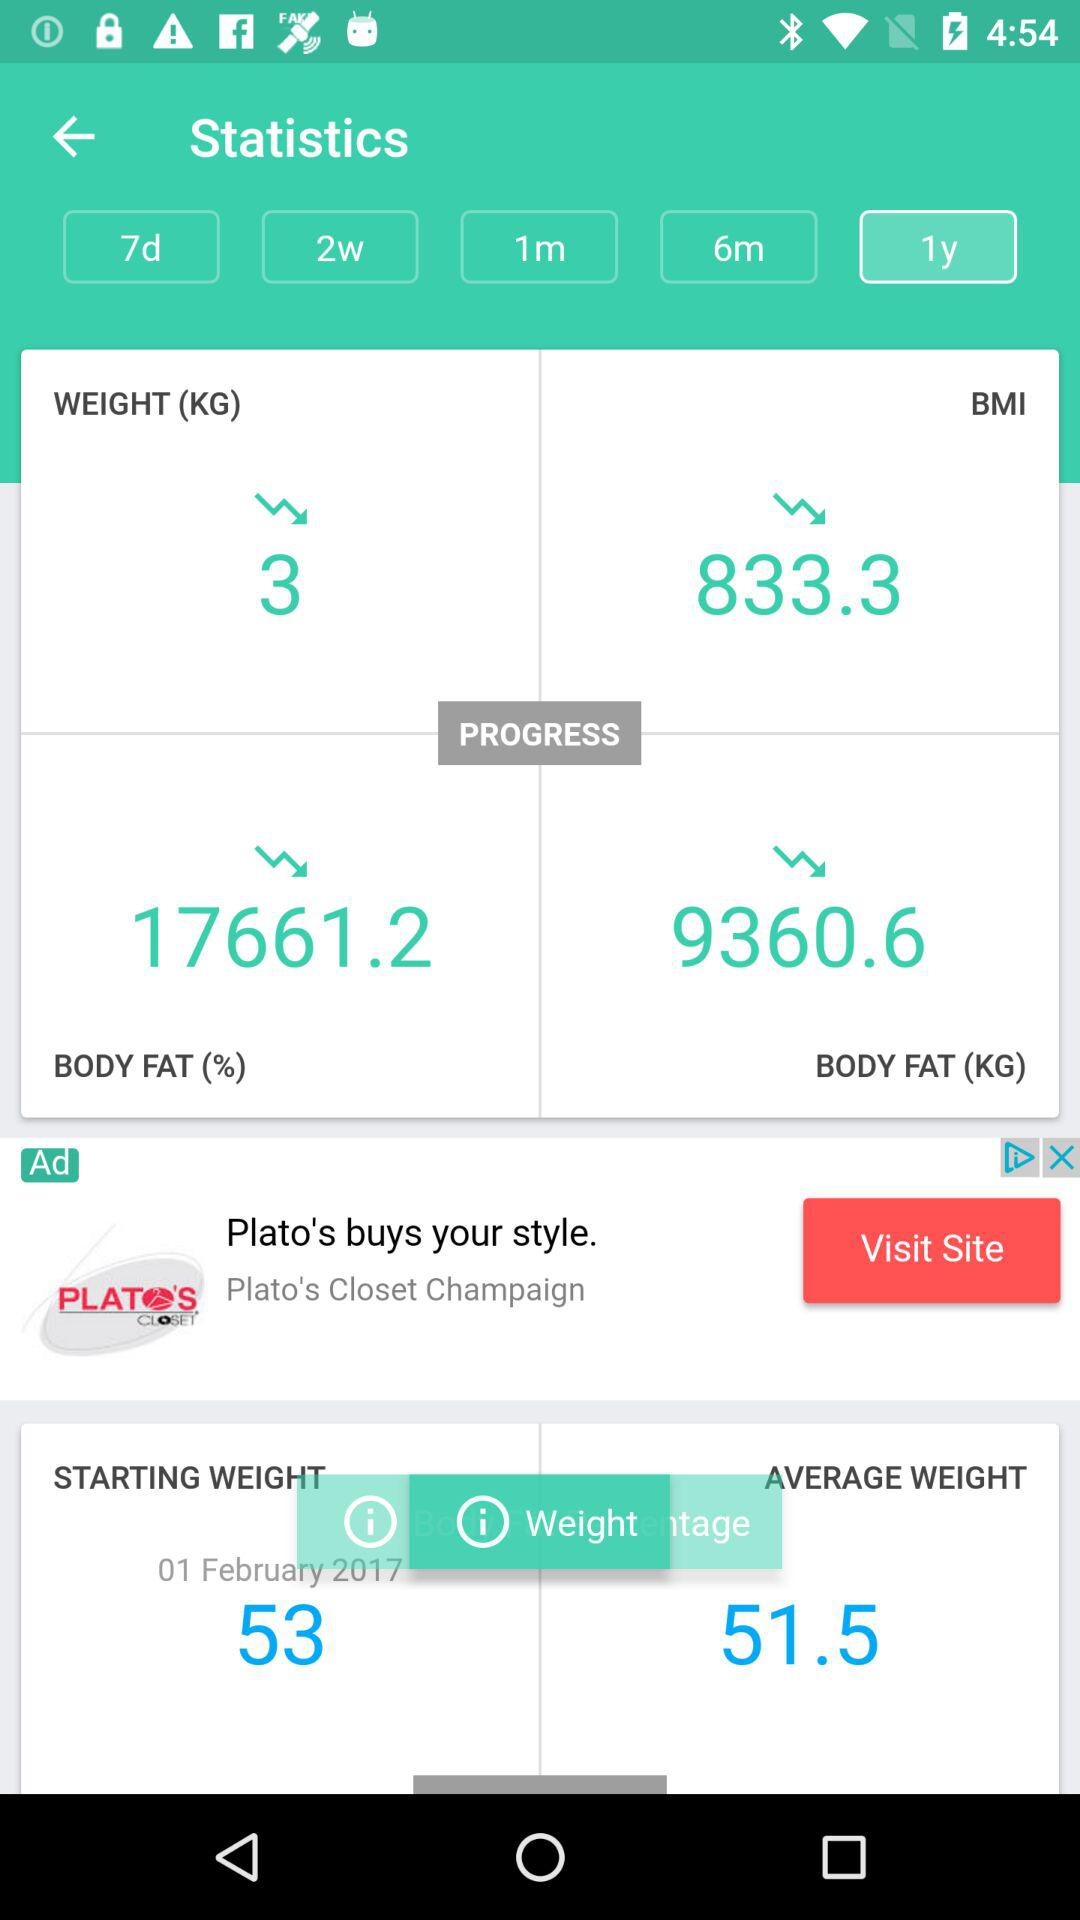What was the weight on the starting date?
When the provided information is insufficient, respond with <no answer>. <no answer> 